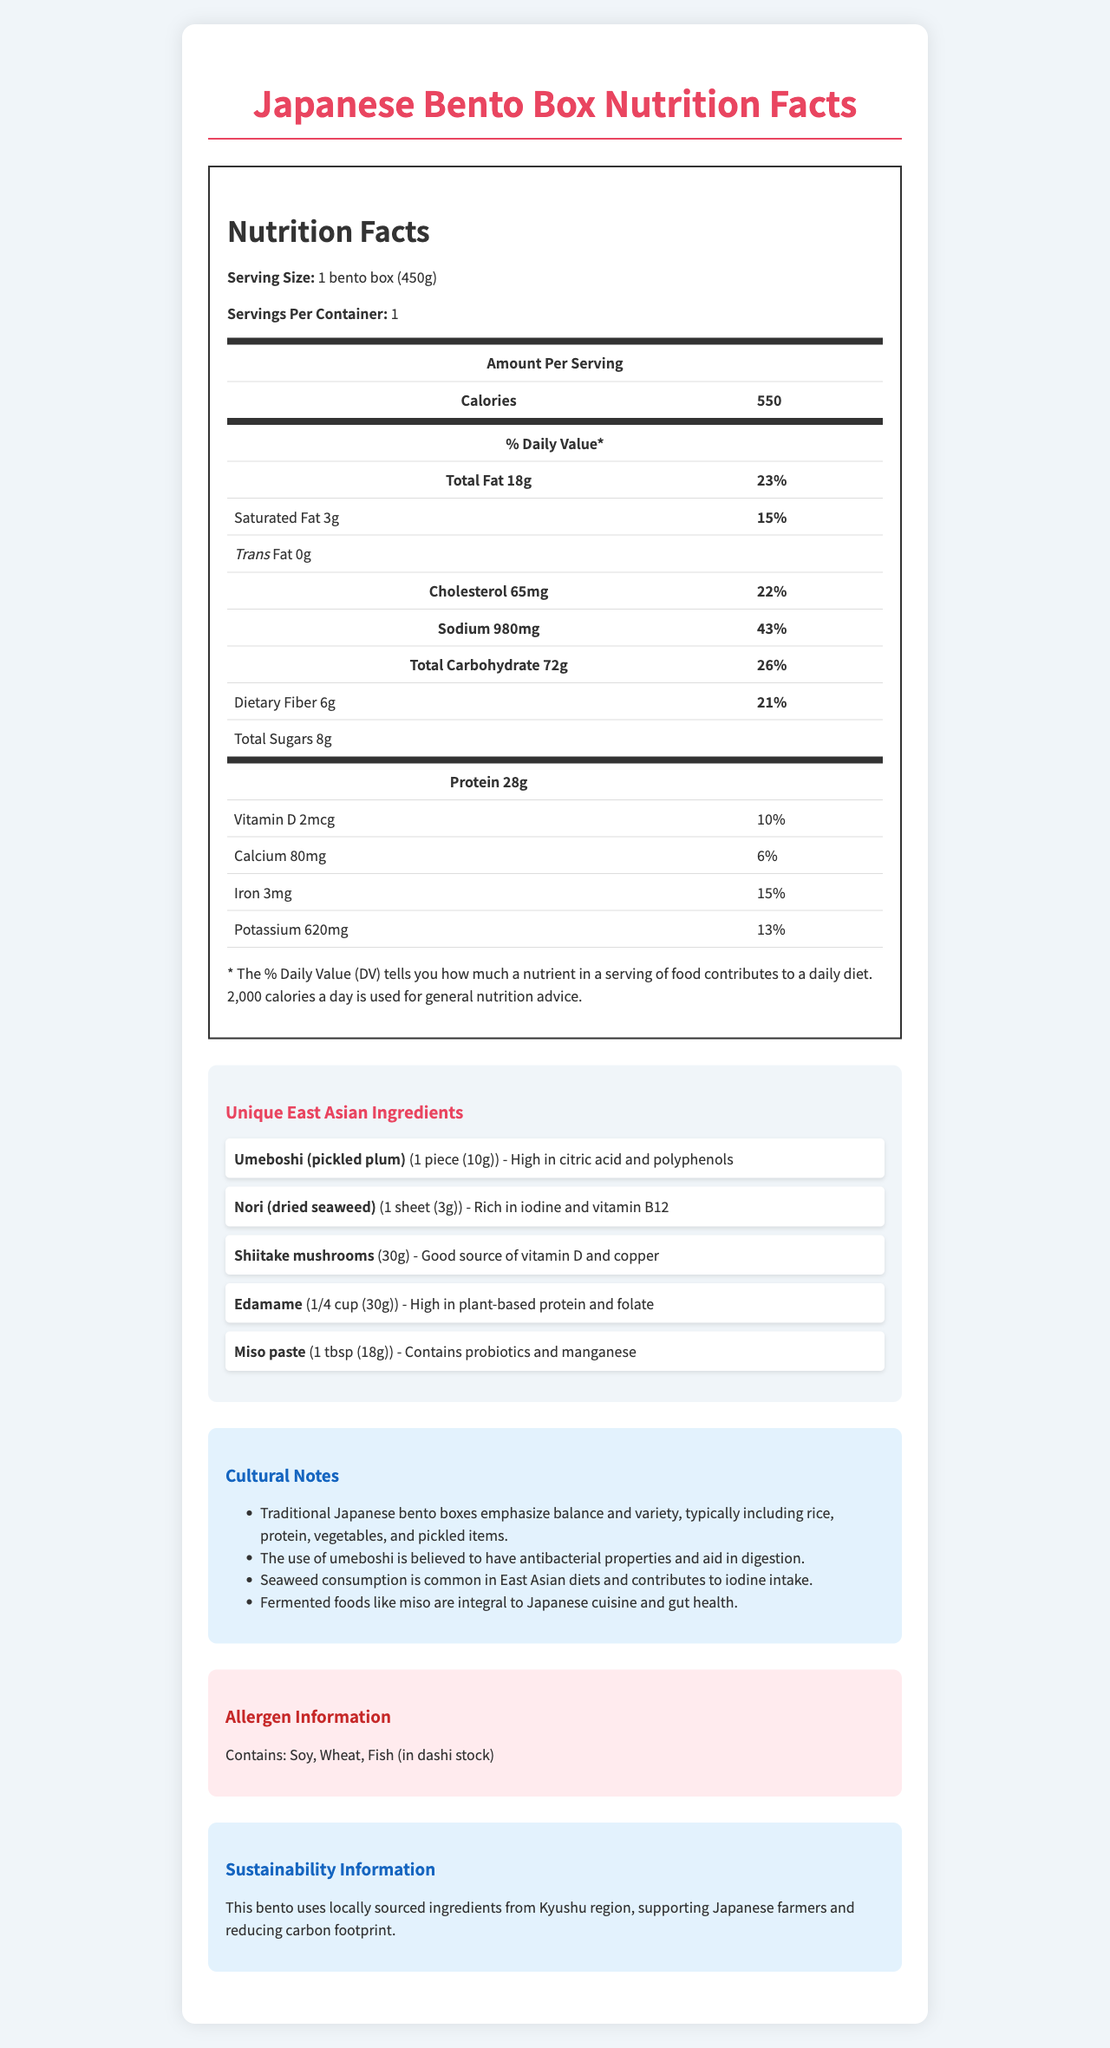what is the serving size of the Japanese bento box? The serving size is listed under the Nutrition Facts section as "1 bento box (450g)".
Answer: 1 bento box (450g) how many calories are in one serving of this bento box? The number of calories is specified in the Nutrition Facts section as 550.
Answer: 550 what is the % daily value of sodium in one serving of this bento box? The % daily value of sodium is found in the Nutrition Facts section, listed as 43%.
Answer: 43% what are the unique East Asian ingredients in the bento box? The unique East Asian ingredients are listed under the "Unique East Asian Ingredients" section.
Answer: Umeboshi (pickled plum), Nori (dried seaweed), Shiitake mushrooms, Edamame, Miso paste what notable nutrients does Nori (dried seaweed) contain? Under the "Unique East Asian Ingredients" section, Nori is noted to be rich in iodine and vitamin B12.
Answer: Iodine and vitamin B12 how many grams of protein does edamame contribute to the bento box? A. 5g B. 10g C. 15g D. 20g Edamame is high in plant-based protein, typically contributing approximately 5g of protein per 30g serving, which is 1/4 cup.
Answer: A. 5g what allergen information is provided for the bento box? A. Contains: Nut, Soy, Wheat B. Contains: Soy, Wheat, Fish C. Contains: Dairy, Gluten, Fish D. Contains: Soy, Fish, Nut The allergen information is listed as "Contains: Soy, Wheat, Fish (in dashi stock)" under the "Allergen Information" section.
Answer: B. Contains: Soy, Wheat, Fish which of the following is not a source of probiotics? 1. Edamame 2. Nori 3. Miso paste Probiotics are found in miso paste, as mentioned under its unique ingredient listing. Edamame and Nori are not sources of probiotics.
Answer: 1. Edamame is this bento box made from locally sourced ingredients? According to the "Sustainability Information" section, the bento box uses locally sourced ingredients from the Kyushu region.
Answer: Yes summarize the main idea of this document. The summary includes all key sections: Nutrition Facts, Unique Ingredients, Allergen Information, Cultural Notes, and Sustainability Information, giving a comprehensive overview of the bento box's nutritional and cultural significance.
Answer: The document provides detailed nutrition facts, unique East Asian ingredients, allergen and cultural information, and sustainability details of a traditional Japanese bento box. does the document specify the exact amount of vitamin B12 in Nori? The document mentions that Nori is rich in vitamin B12 but does not provide the exact amount.
Answer: No 